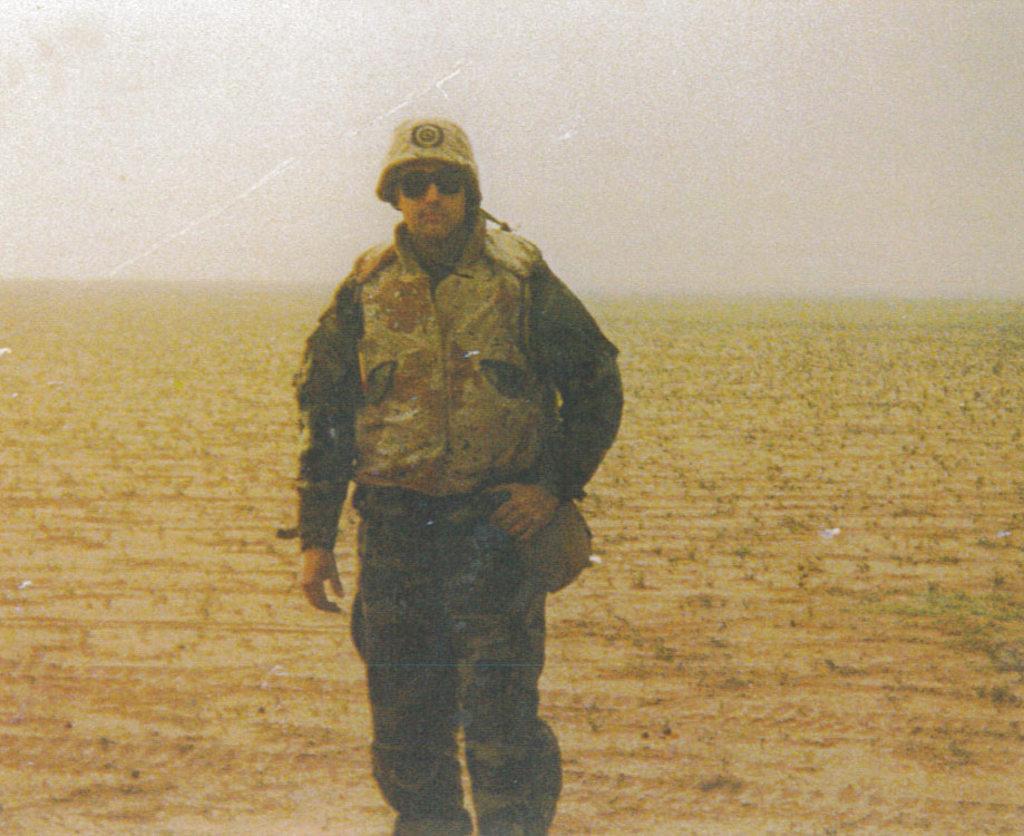Could you give a brief overview of what you see in this image? In this image I can see a person standing, wearing a cap, goggles and a uniform. There is land and there is sky at the top. 